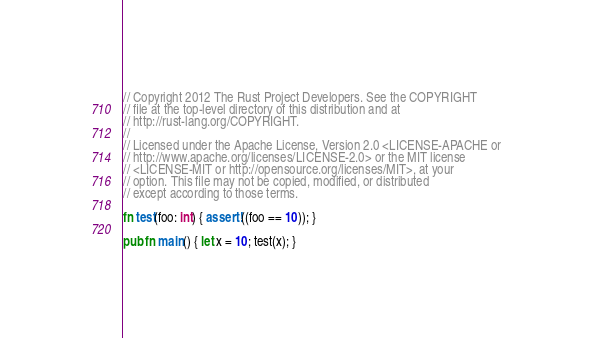Convert code to text. <code><loc_0><loc_0><loc_500><loc_500><_Rust_>// Copyright 2012 The Rust Project Developers. See the COPYRIGHT
// file at the top-level directory of this distribution and at
// http://rust-lang.org/COPYRIGHT.
//
// Licensed under the Apache License, Version 2.0 <LICENSE-APACHE or
// http://www.apache.org/licenses/LICENSE-2.0> or the MIT license
// <LICENSE-MIT or http://opensource.org/licenses/MIT>, at your
// option. This file may not be copied, modified, or distributed
// except according to those terms.

fn test(foo: int) { assert!((foo == 10)); }

pub fn main() { let x = 10; test(x); }
</code> 